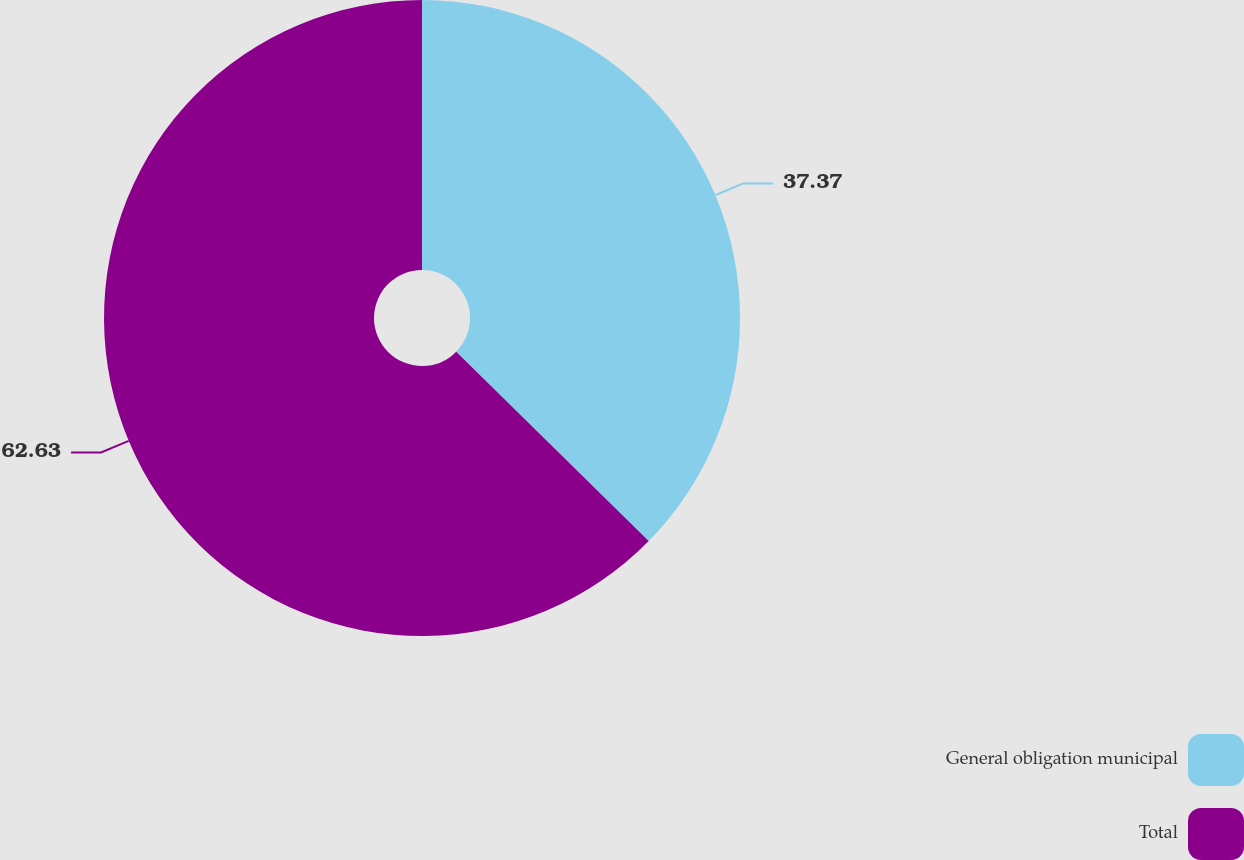<chart> <loc_0><loc_0><loc_500><loc_500><pie_chart><fcel>General obligation municipal<fcel>Total<nl><fcel>37.37%<fcel>62.63%<nl></chart> 